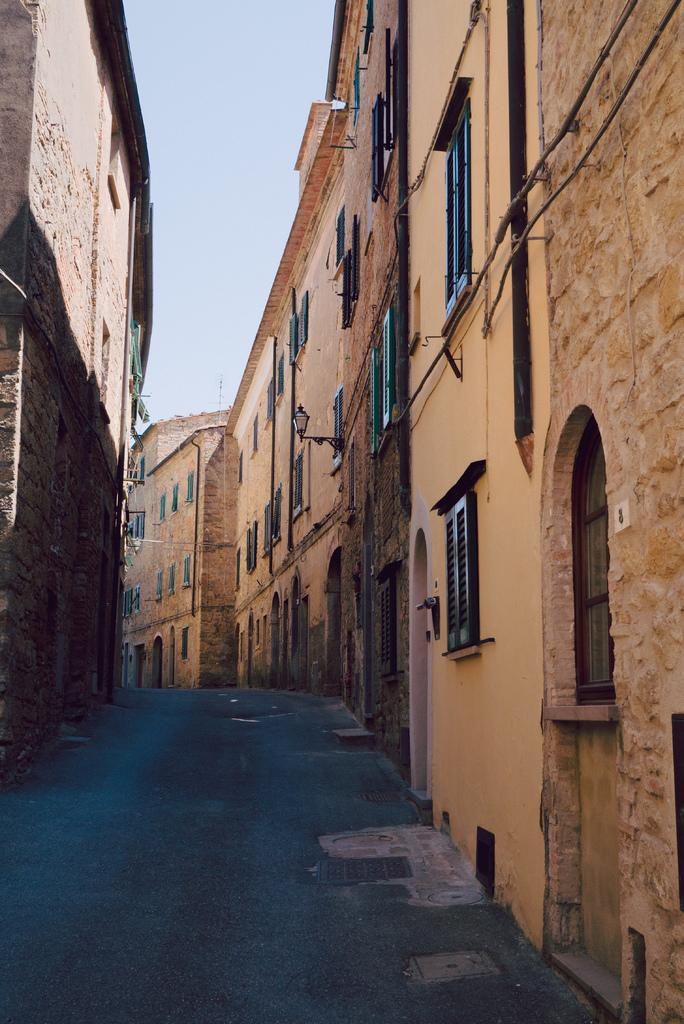What is the main subject of the image? The main subject of the image is a street. What can be seen on both sides of the street? There are buildings on both sides of the street. What is the color of the buildings? The buildings are brown in color. How many windows are visible on the buildings? The buildings have multiple windows. What is visible at the top of the image? The sky is visible at the top of the image. Are there any people wearing masks on the street in the image? There is no information about people or masks in the image; it only shows a street with brown buildings and multiple windows. 